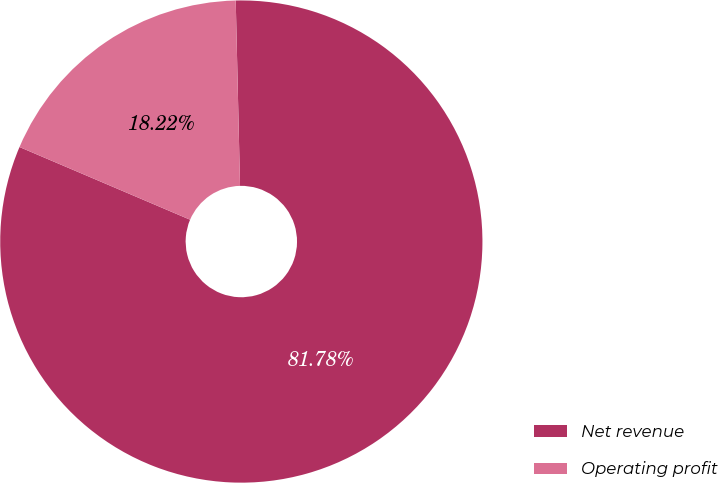<chart> <loc_0><loc_0><loc_500><loc_500><pie_chart><fcel>Net revenue<fcel>Operating profit<nl><fcel>81.78%<fcel>18.22%<nl></chart> 